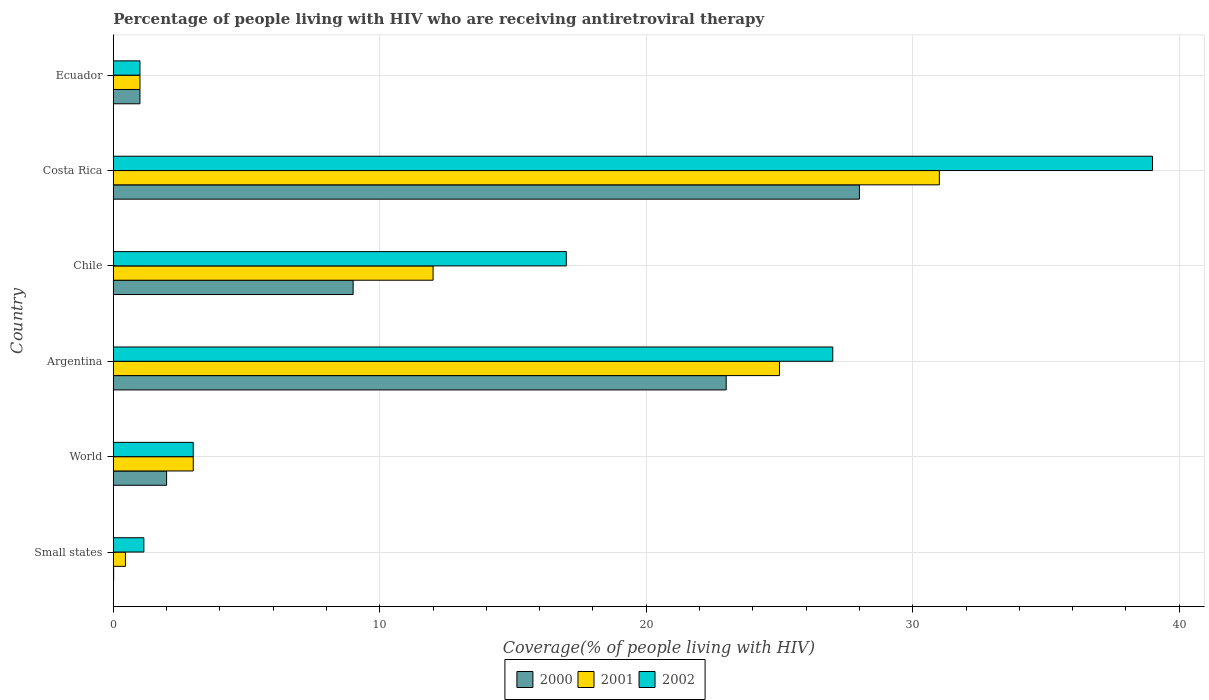How many groups of bars are there?
Ensure brevity in your answer.  6. Are the number of bars per tick equal to the number of legend labels?
Your response must be concise. Yes. How many bars are there on the 5th tick from the top?
Offer a terse response. 3. In how many cases, is the number of bars for a given country not equal to the number of legend labels?
Offer a terse response. 0. What is the percentage of the HIV infected people who are receiving antiretroviral therapy in 2002 in Costa Rica?
Make the answer very short. 39. Across all countries, what is the minimum percentage of the HIV infected people who are receiving antiretroviral therapy in 2001?
Keep it short and to the point. 0.45. In which country was the percentage of the HIV infected people who are receiving antiretroviral therapy in 2002 maximum?
Offer a very short reply. Costa Rica. In which country was the percentage of the HIV infected people who are receiving antiretroviral therapy in 2002 minimum?
Keep it short and to the point. Ecuador. What is the total percentage of the HIV infected people who are receiving antiretroviral therapy in 2000 in the graph?
Offer a very short reply. 63.01. What is the difference between the percentage of the HIV infected people who are receiving antiretroviral therapy in 2000 in Small states and the percentage of the HIV infected people who are receiving antiretroviral therapy in 2001 in Chile?
Your answer should be compact. -11.99. What is the average percentage of the HIV infected people who are receiving antiretroviral therapy in 2001 per country?
Provide a succinct answer. 12.08. What is the difference between the percentage of the HIV infected people who are receiving antiretroviral therapy in 2002 and percentage of the HIV infected people who are receiving antiretroviral therapy in 2001 in Argentina?
Give a very brief answer. 2. In how many countries, is the percentage of the HIV infected people who are receiving antiretroviral therapy in 2001 greater than 22 %?
Your response must be concise. 2. What is the ratio of the percentage of the HIV infected people who are receiving antiretroviral therapy in 2000 in Ecuador to that in Small states?
Provide a succinct answer. 80.36. What is the difference between the highest and the second highest percentage of the HIV infected people who are receiving antiretroviral therapy in 2001?
Your answer should be compact. 6. What is the difference between the highest and the lowest percentage of the HIV infected people who are receiving antiretroviral therapy in 2000?
Keep it short and to the point. 27.99. In how many countries, is the percentage of the HIV infected people who are receiving antiretroviral therapy in 2000 greater than the average percentage of the HIV infected people who are receiving antiretroviral therapy in 2000 taken over all countries?
Provide a succinct answer. 2. Is the sum of the percentage of the HIV infected people who are receiving antiretroviral therapy in 2000 in Chile and World greater than the maximum percentage of the HIV infected people who are receiving antiretroviral therapy in 2002 across all countries?
Make the answer very short. No. What does the 2nd bar from the top in Argentina represents?
Offer a terse response. 2001. How many countries are there in the graph?
Make the answer very short. 6. What is the difference between two consecutive major ticks on the X-axis?
Keep it short and to the point. 10. Are the values on the major ticks of X-axis written in scientific E-notation?
Offer a terse response. No. Where does the legend appear in the graph?
Your response must be concise. Bottom center. How many legend labels are there?
Offer a terse response. 3. What is the title of the graph?
Provide a short and direct response. Percentage of people living with HIV who are receiving antiretroviral therapy. Does "1995" appear as one of the legend labels in the graph?
Offer a terse response. No. What is the label or title of the X-axis?
Ensure brevity in your answer.  Coverage(% of people living with HIV). What is the Coverage(% of people living with HIV) in 2000 in Small states?
Offer a very short reply. 0.01. What is the Coverage(% of people living with HIV) of 2001 in Small states?
Your answer should be very brief. 0.45. What is the Coverage(% of people living with HIV) of 2002 in Small states?
Your response must be concise. 1.15. What is the Coverage(% of people living with HIV) of 2000 in World?
Provide a short and direct response. 2. What is the Coverage(% of people living with HIV) in 2001 in Chile?
Make the answer very short. 12. What is the Coverage(% of people living with HIV) of 2002 in Chile?
Provide a short and direct response. 17. What is the Coverage(% of people living with HIV) in 2001 in Costa Rica?
Provide a succinct answer. 31. What is the Coverage(% of people living with HIV) in 2002 in Costa Rica?
Provide a short and direct response. 39. What is the Coverage(% of people living with HIV) in 2000 in Ecuador?
Give a very brief answer. 1. What is the Coverage(% of people living with HIV) in 2002 in Ecuador?
Your response must be concise. 1. Across all countries, what is the maximum Coverage(% of people living with HIV) of 2000?
Offer a terse response. 28. Across all countries, what is the maximum Coverage(% of people living with HIV) of 2001?
Provide a short and direct response. 31. Across all countries, what is the minimum Coverage(% of people living with HIV) in 2000?
Your response must be concise. 0.01. Across all countries, what is the minimum Coverage(% of people living with HIV) of 2001?
Provide a short and direct response. 0.45. What is the total Coverage(% of people living with HIV) of 2000 in the graph?
Offer a very short reply. 63.01. What is the total Coverage(% of people living with HIV) in 2001 in the graph?
Your response must be concise. 72.45. What is the total Coverage(% of people living with HIV) of 2002 in the graph?
Ensure brevity in your answer.  88.15. What is the difference between the Coverage(% of people living with HIV) of 2000 in Small states and that in World?
Your answer should be very brief. -1.99. What is the difference between the Coverage(% of people living with HIV) in 2001 in Small states and that in World?
Offer a terse response. -2.54. What is the difference between the Coverage(% of people living with HIV) in 2002 in Small states and that in World?
Offer a terse response. -1.85. What is the difference between the Coverage(% of people living with HIV) of 2000 in Small states and that in Argentina?
Keep it short and to the point. -22.99. What is the difference between the Coverage(% of people living with HIV) in 2001 in Small states and that in Argentina?
Offer a terse response. -24.55. What is the difference between the Coverage(% of people living with HIV) in 2002 in Small states and that in Argentina?
Keep it short and to the point. -25.85. What is the difference between the Coverage(% of people living with HIV) in 2000 in Small states and that in Chile?
Make the answer very short. -8.99. What is the difference between the Coverage(% of people living with HIV) of 2001 in Small states and that in Chile?
Offer a terse response. -11.54. What is the difference between the Coverage(% of people living with HIV) of 2002 in Small states and that in Chile?
Provide a short and direct response. -15.85. What is the difference between the Coverage(% of people living with HIV) of 2000 in Small states and that in Costa Rica?
Make the answer very short. -27.99. What is the difference between the Coverage(% of people living with HIV) in 2001 in Small states and that in Costa Rica?
Give a very brief answer. -30.55. What is the difference between the Coverage(% of people living with HIV) of 2002 in Small states and that in Costa Rica?
Your response must be concise. -37.85. What is the difference between the Coverage(% of people living with HIV) in 2000 in Small states and that in Ecuador?
Offer a terse response. -0.99. What is the difference between the Coverage(% of people living with HIV) in 2001 in Small states and that in Ecuador?
Ensure brevity in your answer.  -0.55. What is the difference between the Coverage(% of people living with HIV) of 2002 in Small states and that in Ecuador?
Make the answer very short. 0.15. What is the difference between the Coverage(% of people living with HIV) of 2000 in World and that in Argentina?
Your answer should be very brief. -21. What is the difference between the Coverage(% of people living with HIV) in 2000 in World and that in Chile?
Give a very brief answer. -7. What is the difference between the Coverage(% of people living with HIV) of 2002 in World and that in Chile?
Make the answer very short. -14. What is the difference between the Coverage(% of people living with HIV) of 2000 in World and that in Costa Rica?
Provide a short and direct response. -26. What is the difference between the Coverage(% of people living with HIV) of 2001 in World and that in Costa Rica?
Keep it short and to the point. -28. What is the difference between the Coverage(% of people living with HIV) of 2002 in World and that in Costa Rica?
Your response must be concise. -36. What is the difference between the Coverage(% of people living with HIV) in 2000 in World and that in Ecuador?
Offer a terse response. 1. What is the difference between the Coverage(% of people living with HIV) in 2000 in Argentina and that in Chile?
Ensure brevity in your answer.  14. What is the difference between the Coverage(% of people living with HIV) in 2001 in Argentina and that in Chile?
Provide a succinct answer. 13. What is the difference between the Coverage(% of people living with HIV) of 2002 in Argentina and that in Chile?
Your response must be concise. 10. What is the difference between the Coverage(% of people living with HIV) of 2000 in Argentina and that in Costa Rica?
Your answer should be compact. -5. What is the difference between the Coverage(% of people living with HIV) in 2002 in Argentina and that in Costa Rica?
Your answer should be compact. -12. What is the difference between the Coverage(% of people living with HIV) in 2001 in Argentina and that in Ecuador?
Offer a very short reply. 24. What is the difference between the Coverage(% of people living with HIV) of 2002 in Argentina and that in Ecuador?
Offer a very short reply. 26. What is the difference between the Coverage(% of people living with HIV) of 2000 in Chile and that in Costa Rica?
Provide a succinct answer. -19. What is the difference between the Coverage(% of people living with HIV) of 2002 in Chile and that in Ecuador?
Offer a very short reply. 16. What is the difference between the Coverage(% of people living with HIV) in 2002 in Costa Rica and that in Ecuador?
Keep it short and to the point. 38. What is the difference between the Coverage(% of people living with HIV) of 2000 in Small states and the Coverage(% of people living with HIV) of 2001 in World?
Give a very brief answer. -2.99. What is the difference between the Coverage(% of people living with HIV) of 2000 in Small states and the Coverage(% of people living with HIV) of 2002 in World?
Provide a succinct answer. -2.99. What is the difference between the Coverage(% of people living with HIV) in 2001 in Small states and the Coverage(% of people living with HIV) in 2002 in World?
Your response must be concise. -2.54. What is the difference between the Coverage(% of people living with HIV) in 2000 in Small states and the Coverage(% of people living with HIV) in 2001 in Argentina?
Offer a terse response. -24.99. What is the difference between the Coverage(% of people living with HIV) in 2000 in Small states and the Coverage(% of people living with HIV) in 2002 in Argentina?
Your answer should be very brief. -26.99. What is the difference between the Coverage(% of people living with HIV) of 2001 in Small states and the Coverage(% of people living with HIV) of 2002 in Argentina?
Your answer should be compact. -26.55. What is the difference between the Coverage(% of people living with HIV) in 2000 in Small states and the Coverage(% of people living with HIV) in 2001 in Chile?
Your answer should be compact. -11.99. What is the difference between the Coverage(% of people living with HIV) of 2000 in Small states and the Coverage(% of people living with HIV) of 2002 in Chile?
Offer a terse response. -16.99. What is the difference between the Coverage(% of people living with HIV) in 2001 in Small states and the Coverage(% of people living with HIV) in 2002 in Chile?
Offer a terse response. -16.55. What is the difference between the Coverage(% of people living with HIV) of 2000 in Small states and the Coverage(% of people living with HIV) of 2001 in Costa Rica?
Your response must be concise. -30.99. What is the difference between the Coverage(% of people living with HIV) in 2000 in Small states and the Coverage(% of people living with HIV) in 2002 in Costa Rica?
Make the answer very short. -38.99. What is the difference between the Coverage(% of people living with HIV) in 2001 in Small states and the Coverage(% of people living with HIV) in 2002 in Costa Rica?
Make the answer very short. -38.55. What is the difference between the Coverage(% of people living with HIV) of 2000 in Small states and the Coverage(% of people living with HIV) of 2001 in Ecuador?
Give a very brief answer. -0.99. What is the difference between the Coverage(% of people living with HIV) of 2000 in Small states and the Coverage(% of people living with HIV) of 2002 in Ecuador?
Offer a terse response. -0.99. What is the difference between the Coverage(% of people living with HIV) in 2001 in Small states and the Coverage(% of people living with HIV) in 2002 in Ecuador?
Provide a succinct answer. -0.55. What is the difference between the Coverage(% of people living with HIV) of 2000 in World and the Coverage(% of people living with HIV) of 2001 in Argentina?
Keep it short and to the point. -23. What is the difference between the Coverage(% of people living with HIV) in 2001 in World and the Coverage(% of people living with HIV) in 2002 in Chile?
Offer a very short reply. -14. What is the difference between the Coverage(% of people living with HIV) in 2000 in World and the Coverage(% of people living with HIV) in 2001 in Costa Rica?
Provide a short and direct response. -29. What is the difference between the Coverage(% of people living with HIV) of 2000 in World and the Coverage(% of people living with HIV) of 2002 in Costa Rica?
Make the answer very short. -37. What is the difference between the Coverage(% of people living with HIV) in 2001 in World and the Coverage(% of people living with HIV) in 2002 in Costa Rica?
Provide a succinct answer. -36. What is the difference between the Coverage(% of people living with HIV) of 2001 in World and the Coverage(% of people living with HIV) of 2002 in Ecuador?
Provide a short and direct response. 2. What is the difference between the Coverage(% of people living with HIV) of 2000 in Argentina and the Coverage(% of people living with HIV) of 2001 in Chile?
Your answer should be very brief. 11. What is the difference between the Coverage(% of people living with HIV) in 2000 in Argentina and the Coverage(% of people living with HIV) in 2002 in Chile?
Ensure brevity in your answer.  6. What is the difference between the Coverage(% of people living with HIV) in 2001 in Argentina and the Coverage(% of people living with HIV) in 2002 in Chile?
Provide a short and direct response. 8. What is the difference between the Coverage(% of people living with HIV) of 2001 in Argentina and the Coverage(% of people living with HIV) of 2002 in Costa Rica?
Give a very brief answer. -14. What is the difference between the Coverage(% of people living with HIV) in 2001 in Chile and the Coverage(% of people living with HIV) in 2002 in Costa Rica?
Provide a short and direct response. -27. What is the difference between the Coverage(% of people living with HIV) of 2001 in Chile and the Coverage(% of people living with HIV) of 2002 in Ecuador?
Make the answer very short. 11. What is the difference between the Coverage(% of people living with HIV) of 2000 in Costa Rica and the Coverage(% of people living with HIV) of 2001 in Ecuador?
Offer a terse response. 27. What is the difference between the Coverage(% of people living with HIV) in 2001 in Costa Rica and the Coverage(% of people living with HIV) in 2002 in Ecuador?
Offer a terse response. 30. What is the average Coverage(% of people living with HIV) of 2000 per country?
Provide a short and direct response. 10.5. What is the average Coverage(% of people living with HIV) in 2001 per country?
Keep it short and to the point. 12.08. What is the average Coverage(% of people living with HIV) in 2002 per country?
Your response must be concise. 14.69. What is the difference between the Coverage(% of people living with HIV) of 2000 and Coverage(% of people living with HIV) of 2001 in Small states?
Keep it short and to the point. -0.44. What is the difference between the Coverage(% of people living with HIV) in 2000 and Coverage(% of people living with HIV) in 2002 in Small states?
Provide a succinct answer. -1.13. What is the difference between the Coverage(% of people living with HIV) in 2001 and Coverage(% of people living with HIV) in 2002 in Small states?
Your answer should be compact. -0.69. What is the difference between the Coverage(% of people living with HIV) in 2001 and Coverage(% of people living with HIV) in 2002 in Argentina?
Your answer should be compact. -2. What is the difference between the Coverage(% of people living with HIV) of 2001 and Coverage(% of people living with HIV) of 2002 in Chile?
Your answer should be compact. -5. What is the difference between the Coverage(% of people living with HIV) in 2000 and Coverage(% of people living with HIV) in 2001 in Costa Rica?
Provide a short and direct response. -3. What is the difference between the Coverage(% of people living with HIV) in 2000 and Coverage(% of people living with HIV) in 2001 in Ecuador?
Your answer should be compact. 0. What is the difference between the Coverage(% of people living with HIV) of 2001 and Coverage(% of people living with HIV) of 2002 in Ecuador?
Your answer should be compact. 0. What is the ratio of the Coverage(% of people living with HIV) in 2000 in Small states to that in World?
Offer a terse response. 0.01. What is the ratio of the Coverage(% of people living with HIV) of 2001 in Small states to that in World?
Your answer should be compact. 0.15. What is the ratio of the Coverage(% of people living with HIV) of 2002 in Small states to that in World?
Offer a very short reply. 0.38. What is the ratio of the Coverage(% of people living with HIV) in 2000 in Small states to that in Argentina?
Your answer should be very brief. 0. What is the ratio of the Coverage(% of people living with HIV) in 2001 in Small states to that in Argentina?
Offer a terse response. 0.02. What is the ratio of the Coverage(% of people living with HIV) in 2002 in Small states to that in Argentina?
Provide a succinct answer. 0.04. What is the ratio of the Coverage(% of people living with HIV) of 2000 in Small states to that in Chile?
Offer a terse response. 0. What is the ratio of the Coverage(% of people living with HIV) of 2001 in Small states to that in Chile?
Provide a short and direct response. 0.04. What is the ratio of the Coverage(% of people living with HIV) of 2002 in Small states to that in Chile?
Your answer should be very brief. 0.07. What is the ratio of the Coverage(% of people living with HIV) in 2001 in Small states to that in Costa Rica?
Offer a very short reply. 0.01. What is the ratio of the Coverage(% of people living with HIV) of 2002 in Small states to that in Costa Rica?
Offer a terse response. 0.03. What is the ratio of the Coverage(% of people living with HIV) in 2000 in Small states to that in Ecuador?
Your answer should be compact. 0.01. What is the ratio of the Coverage(% of people living with HIV) in 2001 in Small states to that in Ecuador?
Provide a short and direct response. 0.46. What is the ratio of the Coverage(% of people living with HIV) of 2002 in Small states to that in Ecuador?
Give a very brief answer. 1.15. What is the ratio of the Coverage(% of people living with HIV) of 2000 in World to that in Argentina?
Provide a succinct answer. 0.09. What is the ratio of the Coverage(% of people living with HIV) of 2001 in World to that in Argentina?
Your response must be concise. 0.12. What is the ratio of the Coverage(% of people living with HIV) of 2000 in World to that in Chile?
Make the answer very short. 0.22. What is the ratio of the Coverage(% of people living with HIV) in 2001 in World to that in Chile?
Provide a short and direct response. 0.25. What is the ratio of the Coverage(% of people living with HIV) in 2002 in World to that in Chile?
Offer a terse response. 0.18. What is the ratio of the Coverage(% of people living with HIV) of 2000 in World to that in Costa Rica?
Provide a short and direct response. 0.07. What is the ratio of the Coverage(% of people living with HIV) of 2001 in World to that in Costa Rica?
Offer a terse response. 0.1. What is the ratio of the Coverage(% of people living with HIV) of 2002 in World to that in Costa Rica?
Offer a very short reply. 0.08. What is the ratio of the Coverage(% of people living with HIV) in 2000 in World to that in Ecuador?
Keep it short and to the point. 2. What is the ratio of the Coverage(% of people living with HIV) in 2001 in World to that in Ecuador?
Offer a terse response. 3. What is the ratio of the Coverage(% of people living with HIV) in 2002 in World to that in Ecuador?
Offer a very short reply. 3. What is the ratio of the Coverage(% of people living with HIV) in 2000 in Argentina to that in Chile?
Provide a short and direct response. 2.56. What is the ratio of the Coverage(% of people living with HIV) of 2001 in Argentina to that in Chile?
Give a very brief answer. 2.08. What is the ratio of the Coverage(% of people living with HIV) in 2002 in Argentina to that in Chile?
Your response must be concise. 1.59. What is the ratio of the Coverage(% of people living with HIV) in 2000 in Argentina to that in Costa Rica?
Make the answer very short. 0.82. What is the ratio of the Coverage(% of people living with HIV) in 2001 in Argentina to that in Costa Rica?
Your answer should be compact. 0.81. What is the ratio of the Coverage(% of people living with HIV) of 2002 in Argentina to that in Costa Rica?
Make the answer very short. 0.69. What is the ratio of the Coverage(% of people living with HIV) in 2000 in Argentina to that in Ecuador?
Offer a terse response. 23. What is the ratio of the Coverage(% of people living with HIV) in 2001 in Argentina to that in Ecuador?
Provide a succinct answer. 25. What is the ratio of the Coverage(% of people living with HIV) of 2000 in Chile to that in Costa Rica?
Provide a succinct answer. 0.32. What is the ratio of the Coverage(% of people living with HIV) in 2001 in Chile to that in Costa Rica?
Offer a terse response. 0.39. What is the ratio of the Coverage(% of people living with HIV) of 2002 in Chile to that in Costa Rica?
Keep it short and to the point. 0.44. What is the ratio of the Coverage(% of people living with HIV) in 2001 in Chile to that in Ecuador?
Make the answer very short. 12. What is the difference between the highest and the second highest Coverage(% of people living with HIV) in 2000?
Provide a short and direct response. 5. What is the difference between the highest and the second highest Coverage(% of people living with HIV) in 2002?
Give a very brief answer. 12. What is the difference between the highest and the lowest Coverage(% of people living with HIV) in 2000?
Ensure brevity in your answer.  27.99. What is the difference between the highest and the lowest Coverage(% of people living with HIV) of 2001?
Provide a short and direct response. 30.55. What is the difference between the highest and the lowest Coverage(% of people living with HIV) in 2002?
Offer a terse response. 38. 